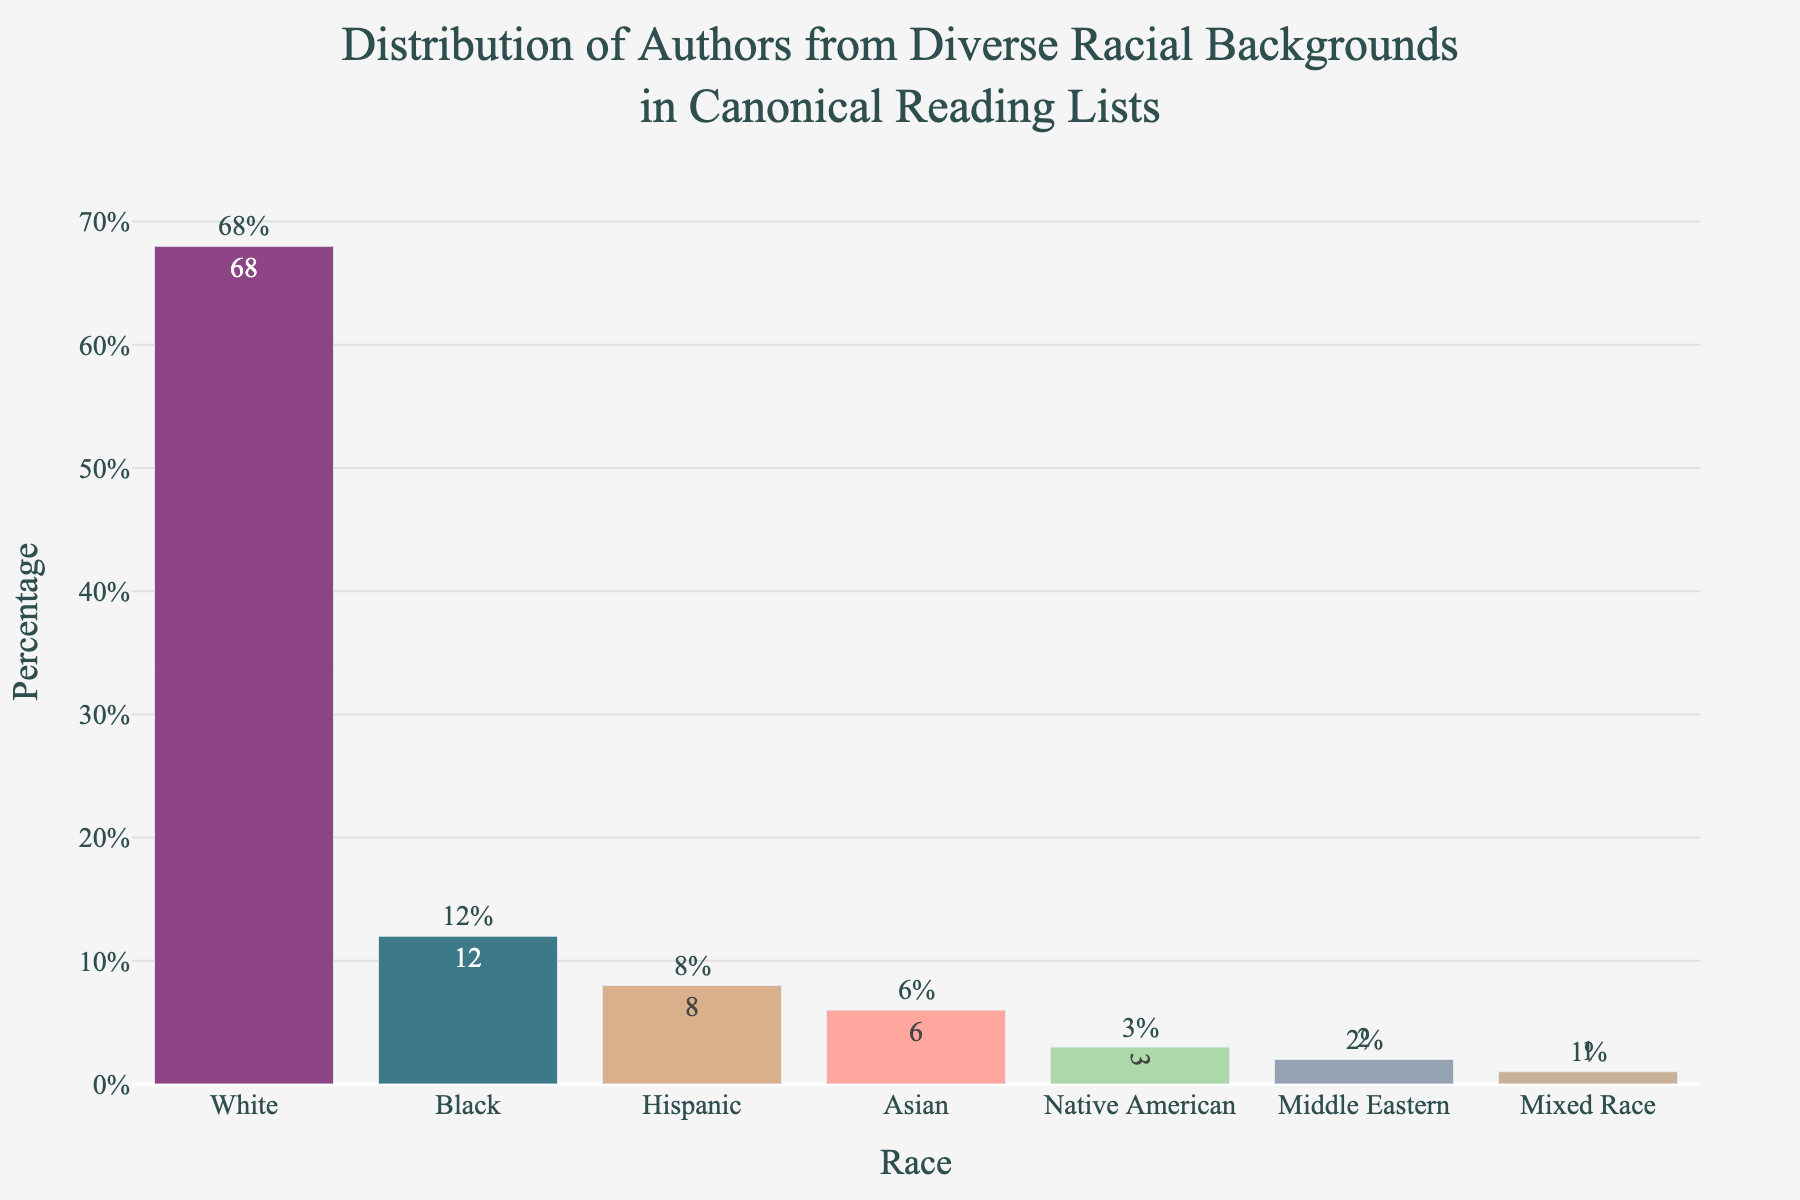What percentage of authors in canonical reading lists are from minority racial backgrounds? Add up the percentages for Black (12%), Hispanic (8%), Asian (6%), Native American (3%), Middle Eastern (2%), and Mixed Race (1%). The total is 12 + 8 + 6 + 3 + 2 + 1 = 32%.
Answer: 32% What race has the highest representation among authors in the canonical reading lists? According to the bar heights, the highest percentage is for White authors, which is 68%.
Answer: White How much more represented are White authors compared to Black authors in canonical reading lists? Subtract the percentage for Black authors (12%) from that of White authors (68%), yielding 68% - 12% = 56%.
Answer: 56% Which racial group has the lowest representation among authors in canonical reading lists? Visually, the Mixed Race category has the smallest bar height, corresponding to 1%.
Answer: Mixed Race If we consider authors from Hispanic and Asian backgrounds together, what is their combined percentage? Add the percentages for Hispanic (8%) and Asian (6%) authors, resulting in 8% + 6% = 14%.
Answer: 14% How many racial groups have a representation percentage less than or equal to 6%? The groups with percentages less than or equal to 6% are Asian (6%), Native American (3%), Middle Eastern (2%), and Mixed Race (1%). This adds up to 4 groups.
Answer: 4 What is the percentage difference between authors from Native American and Middle Eastern backgrounds? Subtract the percentage for Middle Eastern authors (2%) from that of Native American authors (3%), which results in 3% - 2% = 1%.
Answer: 1% What is the second highest represented racial group among authors in canonical reading lists? The racial group with the second highest percentage is Black, with a representation of 12%.
Answer: Black Compare the representation of authors from Hispanic and Native American backgrounds. Which group is more represented and by how much? Hispanic authors have a representation of 8%, while Native American authors have 3%. The difference is 8% - 3% = 5%.
Answer: Hispanic by 5% If the representation of Mixed Race authors doubled, what would be their new percentage in the canonical reading lists? The current percentage for Mixed Race authors is 1%. Doubling this value would be 1% * 2 = 2%.
Answer: 2% 